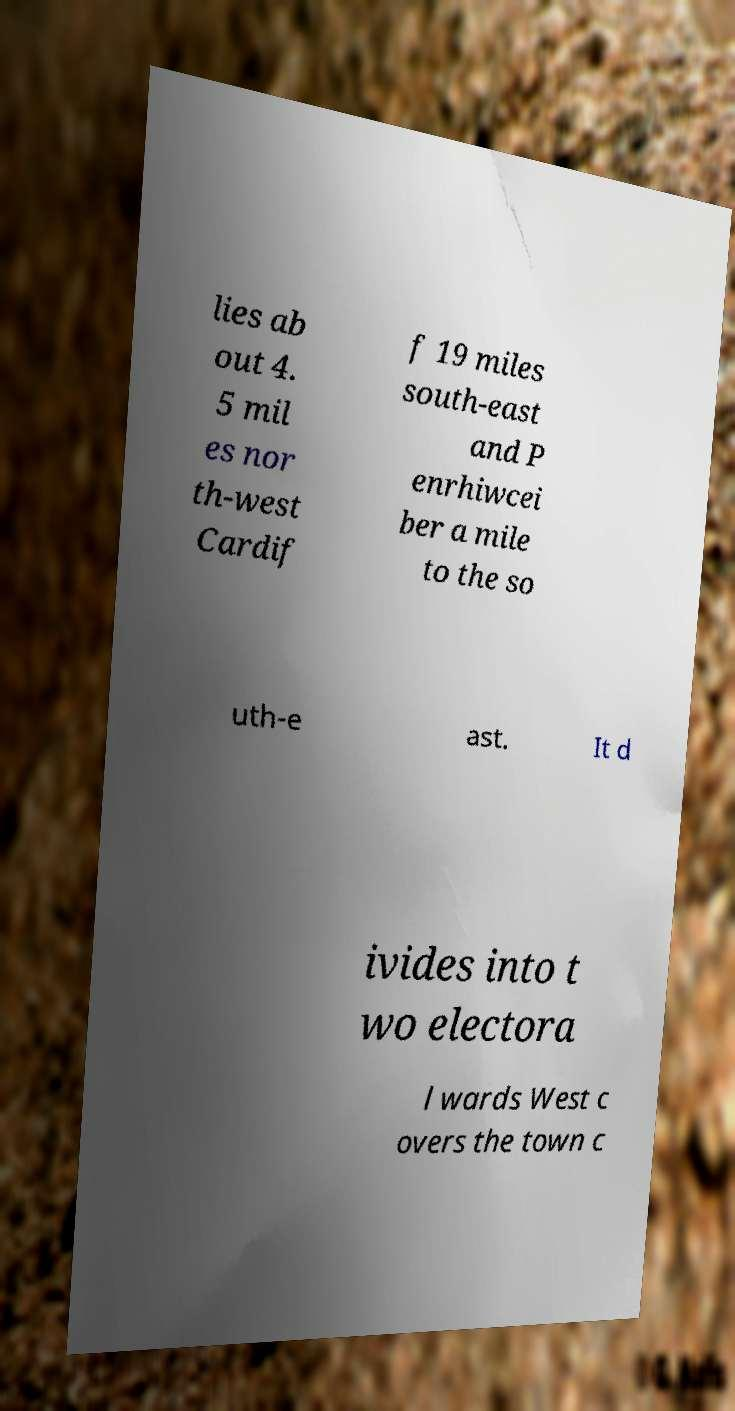Could you assist in decoding the text presented in this image and type it out clearly? lies ab out 4. 5 mil es nor th-west Cardif f 19 miles south-east and P enrhiwcei ber a mile to the so uth-e ast. It d ivides into t wo electora l wards West c overs the town c 